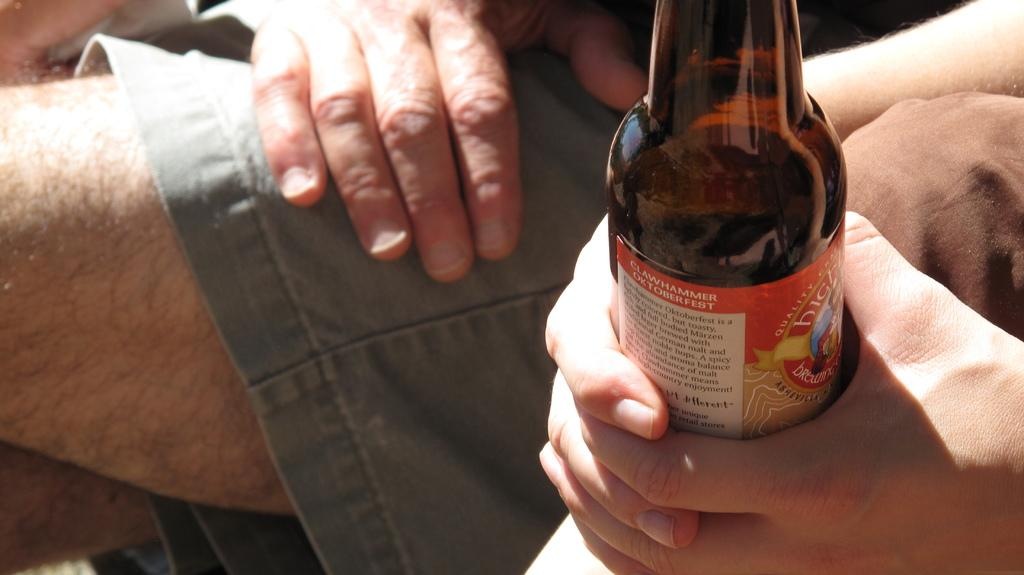What is in the image that is related to a beverage? There is a beer bottle in the image. Can you describe any other elements in the image? A person's hand is visible in the image. What type of net is being used to catch the representative in the image? There is no net or representative present in the image; it only features a beer bottle and a person's hand. 